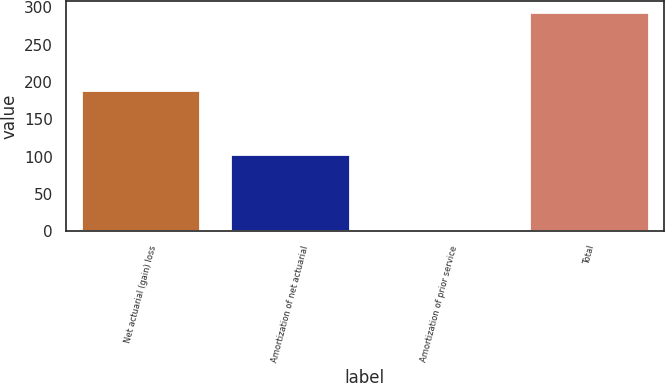Convert chart. <chart><loc_0><loc_0><loc_500><loc_500><bar_chart><fcel>Net actuarial (gain) loss<fcel>Amortization of net actuarial<fcel>Amortization of prior service<fcel>Total<nl><fcel>189.8<fcel>103.3<fcel>2.3<fcel>293.5<nl></chart> 